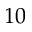Convert formula to latex. <formula><loc_0><loc_0><loc_500><loc_500>1 0</formula> 